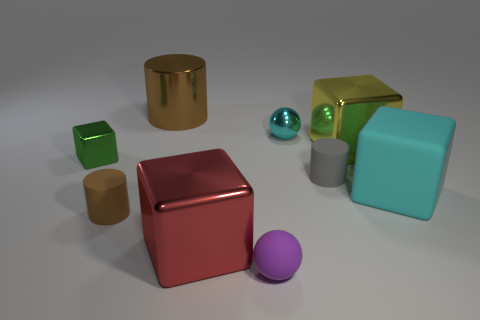There is a big cyan rubber object; is it the same shape as the big metallic thing on the right side of the gray thing?
Offer a terse response. Yes. Are there fewer gray objects in front of the tiny purple rubber sphere than big objects that are right of the large cyan object?
Provide a short and direct response. No. Is there anything else that is the same shape as the large red shiny thing?
Keep it short and to the point. Yes. Do the large cyan object and the small purple matte object have the same shape?
Your answer should be very brief. No. Are there any other things that are the same material as the tiny gray cylinder?
Ensure brevity in your answer.  Yes. The purple ball is what size?
Keep it short and to the point. Small. The big cube that is both in front of the big yellow object and to the left of the large cyan rubber cube is what color?
Offer a terse response. Red. Are there more brown shiny things than large yellow balls?
Your response must be concise. Yes. What number of objects are either purple rubber things or cylinders that are to the left of the purple thing?
Provide a short and direct response. 3. Is the gray cylinder the same size as the cyan sphere?
Your response must be concise. Yes. 